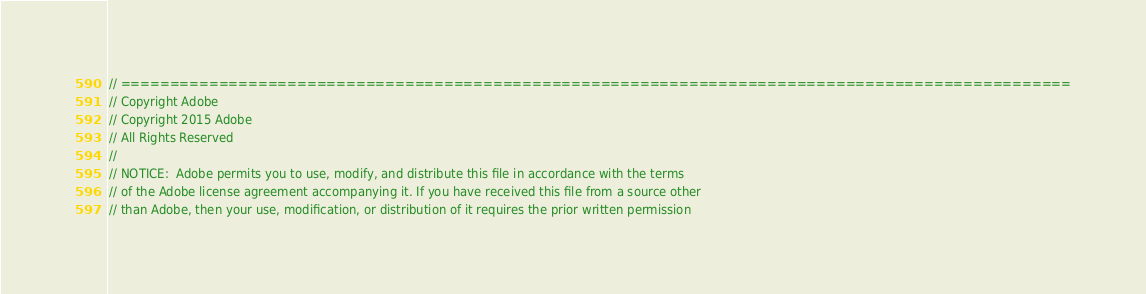<code> <loc_0><loc_0><loc_500><loc_500><_C++_>// =================================================================================================
// Copyright Adobe
// Copyright 2015 Adobe
// All Rights Reserved
//
// NOTICE:  Adobe permits you to use, modify, and distribute this file in accordance with the terms
// of the Adobe license agreement accompanying it. If you have received this file from a source other 
// than Adobe, then your use, modification, or distribution of it requires the prior written permission</code> 